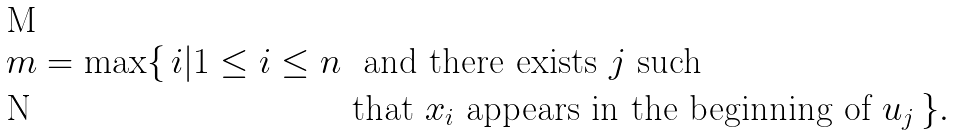<formula> <loc_0><loc_0><loc_500><loc_500>m = \max \{ \, i | 1 \leq i \leq n \ & \text { and there exists $j$ such} \\ & \text {that $x_{i}$ appears in the beginning of $u_{j}$} \, \} .</formula> 